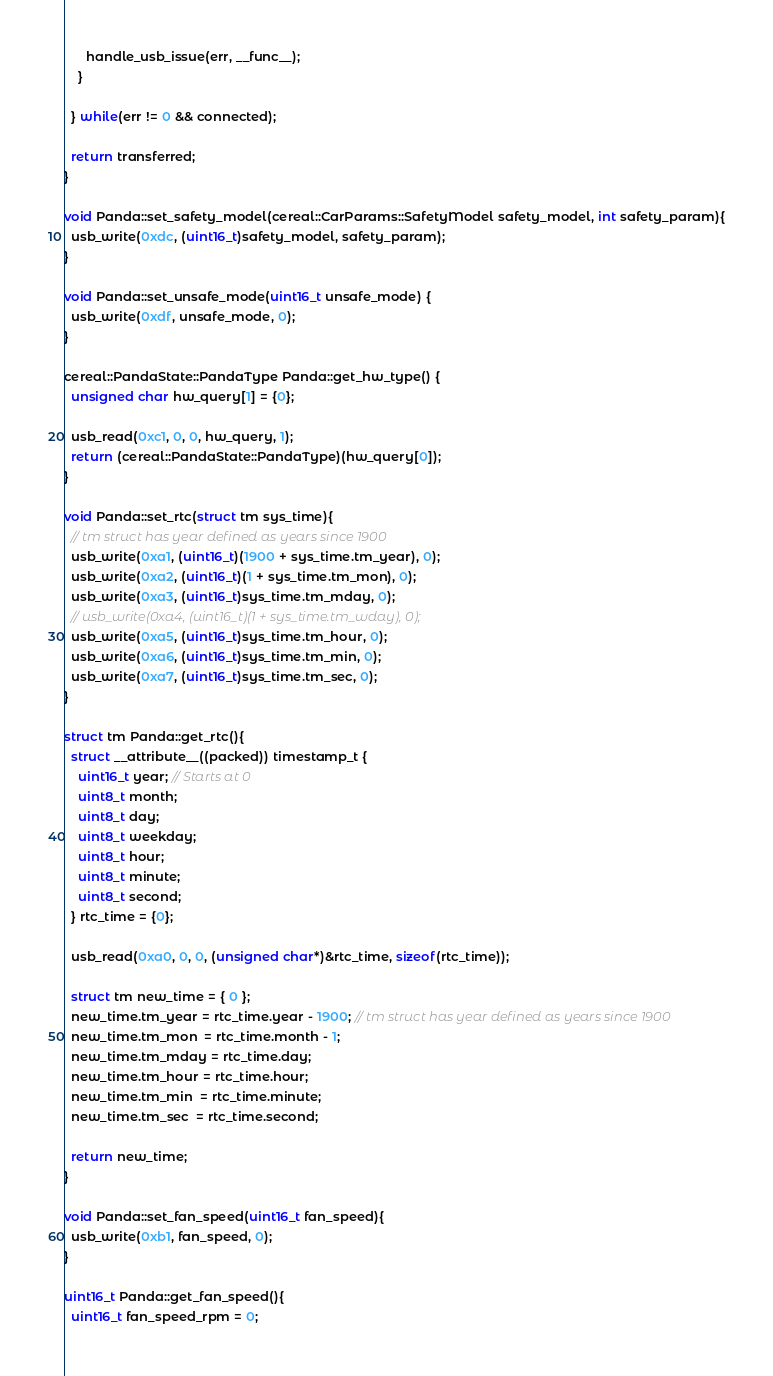<code> <loc_0><loc_0><loc_500><loc_500><_C++_>      handle_usb_issue(err, __func__);
    }

  } while(err != 0 && connected);

  return transferred;
}

void Panda::set_safety_model(cereal::CarParams::SafetyModel safety_model, int safety_param){
  usb_write(0xdc, (uint16_t)safety_model, safety_param);
}

void Panda::set_unsafe_mode(uint16_t unsafe_mode) {
  usb_write(0xdf, unsafe_mode, 0);
}

cereal::PandaState::PandaType Panda::get_hw_type() {
  unsigned char hw_query[1] = {0};

  usb_read(0xc1, 0, 0, hw_query, 1);
  return (cereal::PandaState::PandaType)(hw_query[0]);
}

void Panda::set_rtc(struct tm sys_time){
  // tm struct has year defined as years since 1900
  usb_write(0xa1, (uint16_t)(1900 + sys_time.tm_year), 0);
  usb_write(0xa2, (uint16_t)(1 + sys_time.tm_mon), 0);
  usb_write(0xa3, (uint16_t)sys_time.tm_mday, 0);
  // usb_write(0xa4, (uint16_t)(1 + sys_time.tm_wday), 0);
  usb_write(0xa5, (uint16_t)sys_time.tm_hour, 0);
  usb_write(0xa6, (uint16_t)sys_time.tm_min, 0);
  usb_write(0xa7, (uint16_t)sys_time.tm_sec, 0);
}

struct tm Panda::get_rtc(){
  struct __attribute__((packed)) timestamp_t {
    uint16_t year; // Starts at 0
    uint8_t month;
    uint8_t day;
    uint8_t weekday;
    uint8_t hour;
    uint8_t minute;
    uint8_t second;
  } rtc_time = {0};

  usb_read(0xa0, 0, 0, (unsigned char*)&rtc_time, sizeof(rtc_time));

  struct tm new_time = { 0 };
  new_time.tm_year = rtc_time.year - 1900; // tm struct has year defined as years since 1900
  new_time.tm_mon  = rtc_time.month - 1;
  new_time.tm_mday = rtc_time.day;
  new_time.tm_hour = rtc_time.hour;
  new_time.tm_min  = rtc_time.minute;
  new_time.tm_sec  = rtc_time.second;

  return new_time;
}

void Panda::set_fan_speed(uint16_t fan_speed){
  usb_write(0xb1, fan_speed, 0);
}

uint16_t Panda::get_fan_speed(){
  uint16_t fan_speed_rpm = 0;</code> 